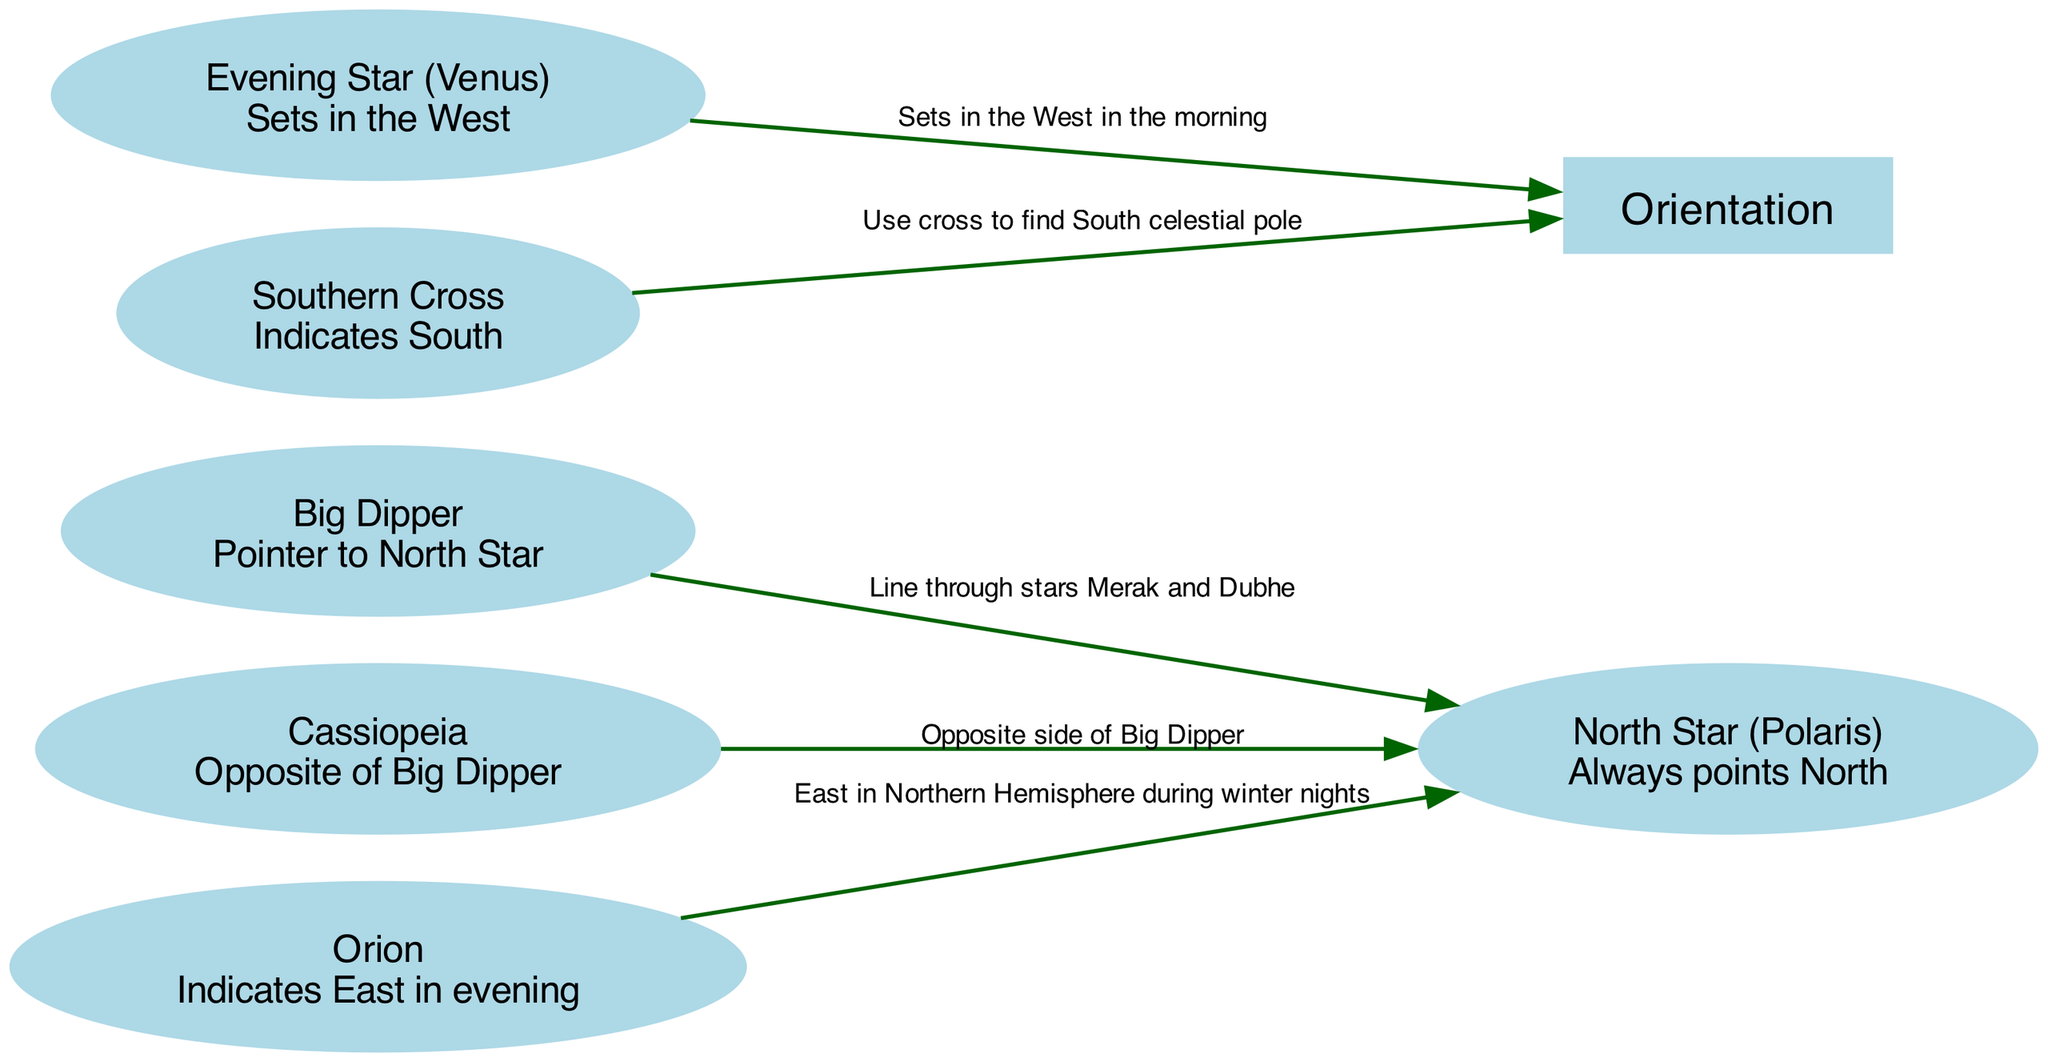What is the name of the star that always points North? The diagram specifies that the North Star, also known as Polaris, is the star that always points North. This is directly indicated as a node description in the diagram.
Answer: North Star (Polaris) How many nodes are there in this diagram? By counting each distinct node in the provided data, we find there are six nodes: North Star, Big Dipper, Cassiopeia, Orion, Evening Star, and Southern Cross.
Answer: 6 Which constellation acts as a pointer to the North Star? The diagram indicates that the Big Dipper points to the North Star. This relationship is represented by an edge connecting the Big Dipper to the North Star.
Answer: Big Dipper What star indicates East in the evening? According to the diagram, the constellation Orion indicates East during the evening. This is specified directly in the node description for Orion.
Answer: Orion Which constellation helps find the South celestial pole? The Southern Cross is shown in the diagram to indicate the direction of the South celestial pole. This is explicitly stated in its node description.
Answer: Southern Cross Which stars form a line to locate the North Star? The diagram illustrates that the line through stars Merak and Dubhe in the Big Dipper forms the connection to find the North Star. This is described in the edge label between the Big Dipper and the North Star.
Answer: Merak and Dubhe What is the direction of the Evening Star when it sets? The Evening Star (Venus) is noted to set in the West. This is conveyed through its node description in the diagram.
Answer: West Which constellation is on the opposite side of the Big Dipper? The diagram specifies that Cassiopeia is on the opposite side of the Big Dipper, which is highlighted in the edge relationship connecting both.
Answer: Cassiopeia How does Orion's position help with navigation in the Northern Hemisphere during winter nights? The diagram details that Orion indicates East during winter nights, which helps in orienting oneself in the night sky for navigation purposes. This relationship is captured in the edge connecting Orion to the North Star.
Answer: East 